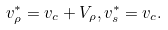<formula> <loc_0><loc_0><loc_500><loc_500>v _ { \rho } ^ { * } = { v } _ { c } + V _ { \rho } , v _ { s } ^ { * } = { v } _ { c } .</formula> 